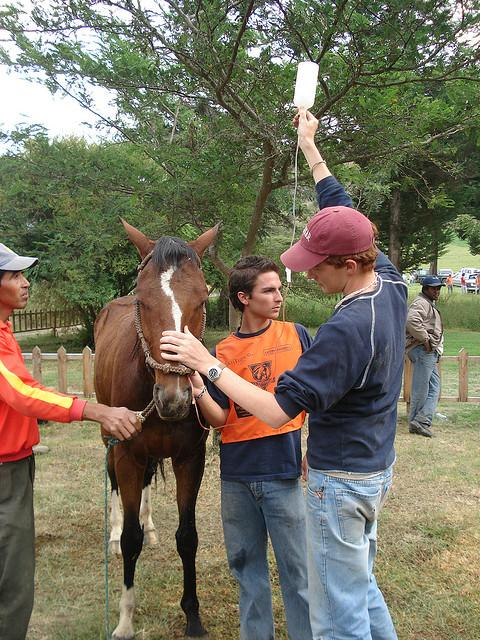What item is held up by the man here? iv bag 